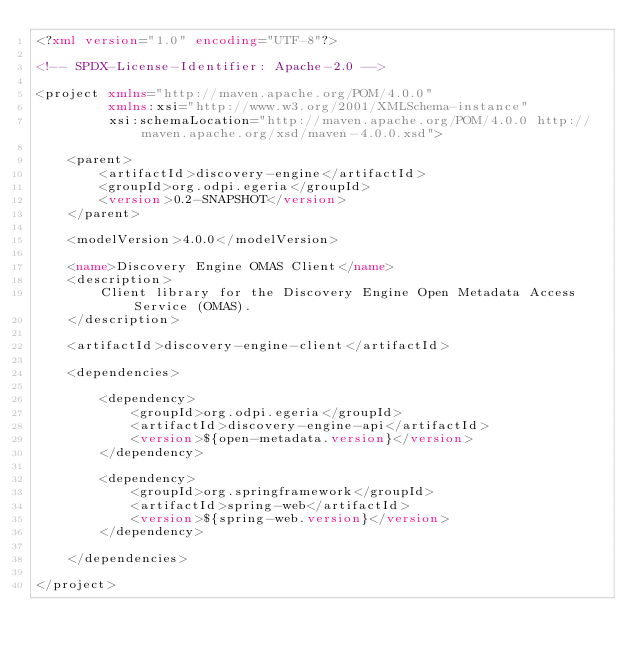Convert code to text. <code><loc_0><loc_0><loc_500><loc_500><_XML_><?xml version="1.0" encoding="UTF-8"?>

<!-- SPDX-License-Identifier: Apache-2.0 -->

<project xmlns="http://maven.apache.org/POM/4.0.0"
         xmlns:xsi="http://www.w3.org/2001/XMLSchema-instance"
         xsi:schemaLocation="http://maven.apache.org/POM/4.0.0 http://maven.apache.org/xsd/maven-4.0.0.xsd">

    <parent>
        <artifactId>discovery-engine</artifactId>
        <groupId>org.odpi.egeria</groupId>
        <version>0.2-SNAPSHOT</version>
    </parent>

    <modelVersion>4.0.0</modelVersion>

    <name>Discovery Engine OMAS Client</name>
    <description>
        Client library for the Discovery Engine Open Metadata Access Service (OMAS).
    </description>

    <artifactId>discovery-engine-client</artifactId>

    <dependencies>

        <dependency>
            <groupId>org.odpi.egeria</groupId>
            <artifactId>discovery-engine-api</artifactId>
            <version>${open-metadata.version}</version>
        </dependency>

        <dependency>
            <groupId>org.springframework</groupId>
            <artifactId>spring-web</artifactId>
            <version>${spring-web.version}</version>
        </dependency>

    </dependencies>

</project></code> 